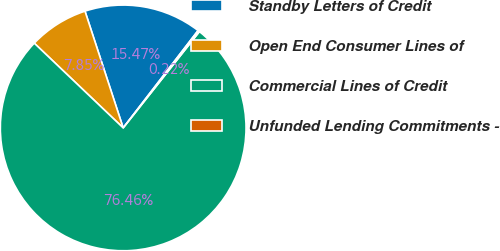<chart> <loc_0><loc_0><loc_500><loc_500><pie_chart><fcel>Standby Letters of Credit<fcel>Open End Consumer Lines of<fcel>Commercial Lines of Credit<fcel>Unfunded Lending Commitments -<nl><fcel>15.47%<fcel>7.85%<fcel>76.46%<fcel>0.22%<nl></chart> 